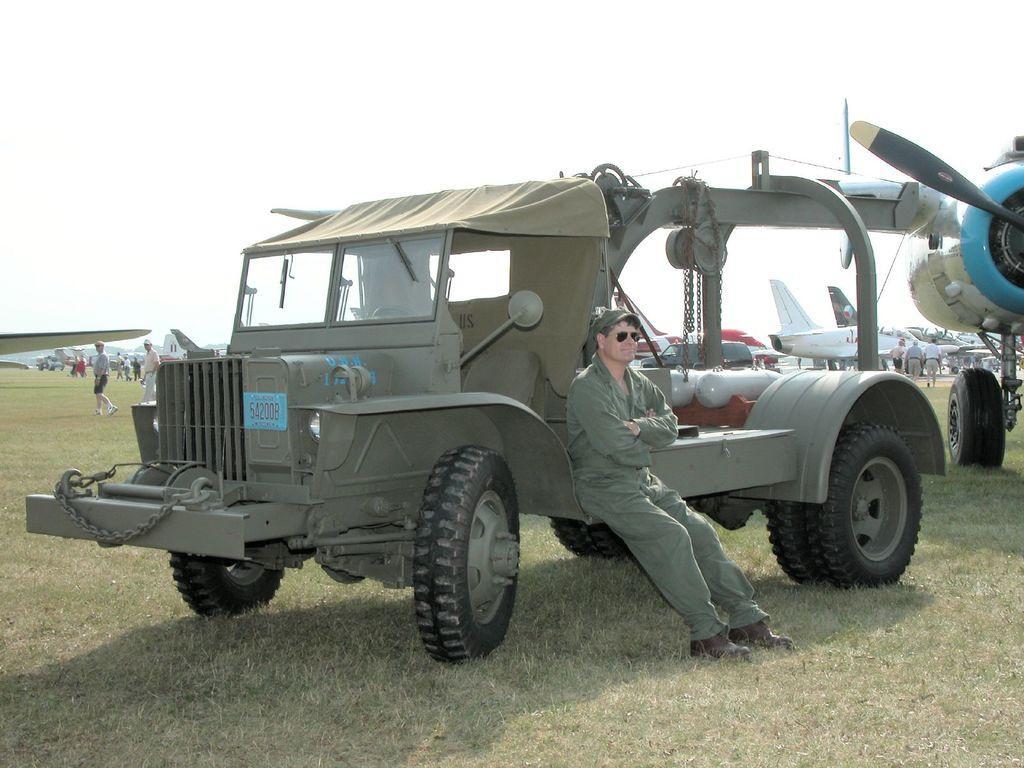Please provide a concise description of this image. There is a person in green color dress sitting on a vehicle which is on the grass on the ground. In the background, there are aircraft and persons on the ground and there is sky. 